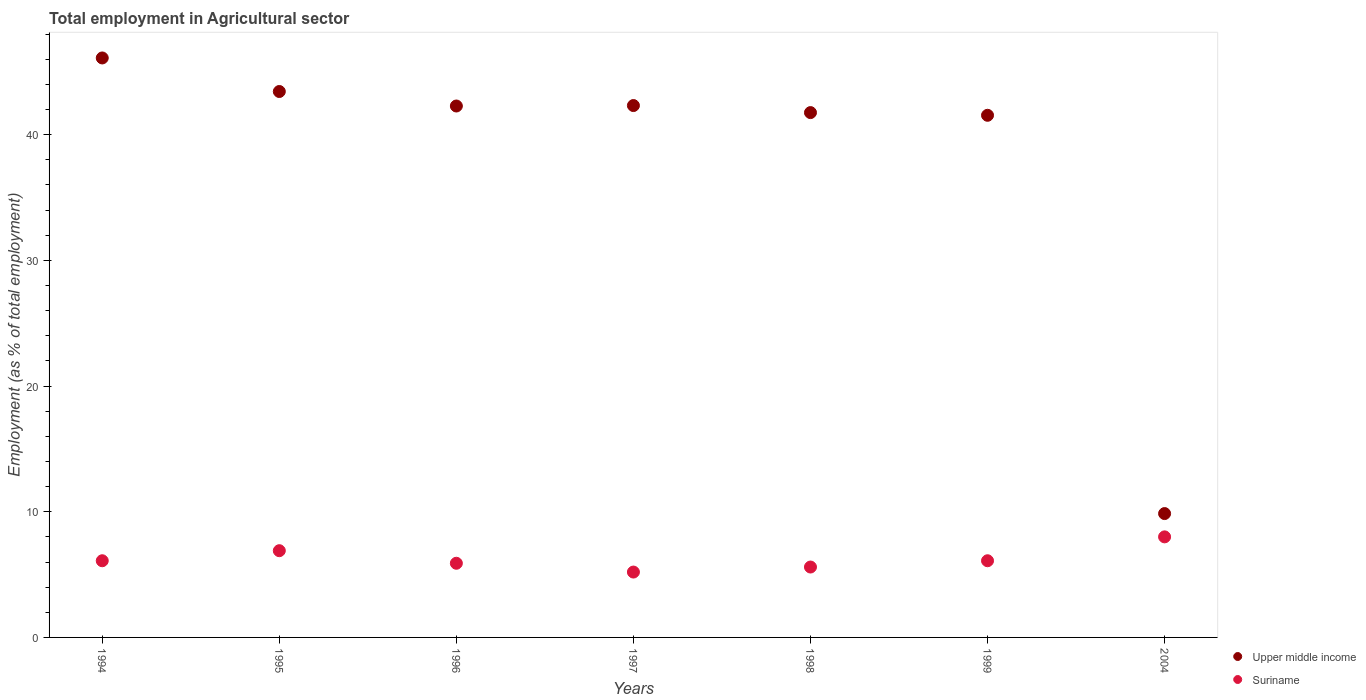What is the employment in agricultural sector in Upper middle income in 1994?
Your answer should be compact. 46.1. Across all years, what is the maximum employment in agricultural sector in Upper middle income?
Make the answer very short. 46.1. Across all years, what is the minimum employment in agricultural sector in Suriname?
Keep it short and to the point. 5.2. In which year was the employment in agricultural sector in Upper middle income maximum?
Keep it short and to the point. 1994. In which year was the employment in agricultural sector in Suriname minimum?
Keep it short and to the point. 1997. What is the total employment in agricultural sector in Upper middle income in the graph?
Provide a succinct answer. 267.26. What is the difference between the employment in agricultural sector in Upper middle income in 1994 and that in 1996?
Offer a terse response. 3.82. What is the difference between the employment in agricultural sector in Suriname in 1994 and the employment in agricultural sector in Upper middle income in 1996?
Your answer should be compact. -36.18. What is the average employment in agricultural sector in Upper middle income per year?
Offer a very short reply. 38.18. In the year 1997, what is the difference between the employment in agricultural sector in Suriname and employment in agricultural sector in Upper middle income?
Offer a terse response. -37.11. What is the difference between the highest and the second highest employment in agricultural sector in Upper middle income?
Offer a terse response. 2.67. What is the difference between the highest and the lowest employment in agricultural sector in Suriname?
Offer a terse response. 2.8. In how many years, is the employment in agricultural sector in Suriname greater than the average employment in agricultural sector in Suriname taken over all years?
Offer a terse response. 2. Is the sum of the employment in agricultural sector in Upper middle income in 1995 and 2004 greater than the maximum employment in agricultural sector in Suriname across all years?
Provide a short and direct response. Yes. Is the employment in agricultural sector in Suriname strictly less than the employment in agricultural sector in Upper middle income over the years?
Offer a very short reply. Yes. Does the graph contain grids?
Your response must be concise. No. What is the title of the graph?
Make the answer very short. Total employment in Agricultural sector. Does "Guyana" appear as one of the legend labels in the graph?
Offer a very short reply. No. What is the label or title of the X-axis?
Keep it short and to the point. Years. What is the label or title of the Y-axis?
Ensure brevity in your answer.  Employment (as % of total employment). What is the Employment (as % of total employment) in Upper middle income in 1994?
Ensure brevity in your answer.  46.1. What is the Employment (as % of total employment) of Suriname in 1994?
Offer a terse response. 6.1. What is the Employment (as % of total employment) in Upper middle income in 1995?
Provide a succinct answer. 43.43. What is the Employment (as % of total employment) in Suriname in 1995?
Provide a succinct answer. 6.9. What is the Employment (as % of total employment) in Upper middle income in 1996?
Make the answer very short. 42.28. What is the Employment (as % of total employment) in Suriname in 1996?
Offer a terse response. 5.9. What is the Employment (as % of total employment) of Upper middle income in 1997?
Give a very brief answer. 42.31. What is the Employment (as % of total employment) of Suriname in 1997?
Make the answer very short. 5.2. What is the Employment (as % of total employment) in Upper middle income in 1998?
Provide a succinct answer. 41.75. What is the Employment (as % of total employment) of Suriname in 1998?
Offer a terse response. 5.6. What is the Employment (as % of total employment) in Upper middle income in 1999?
Provide a short and direct response. 41.54. What is the Employment (as % of total employment) in Suriname in 1999?
Your answer should be very brief. 6.1. What is the Employment (as % of total employment) of Upper middle income in 2004?
Offer a terse response. 9.85. What is the Employment (as % of total employment) of Suriname in 2004?
Keep it short and to the point. 8. Across all years, what is the maximum Employment (as % of total employment) in Upper middle income?
Ensure brevity in your answer.  46.1. Across all years, what is the maximum Employment (as % of total employment) in Suriname?
Make the answer very short. 8. Across all years, what is the minimum Employment (as % of total employment) in Upper middle income?
Provide a short and direct response. 9.85. Across all years, what is the minimum Employment (as % of total employment) of Suriname?
Your answer should be very brief. 5.2. What is the total Employment (as % of total employment) in Upper middle income in the graph?
Your response must be concise. 267.26. What is the total Employment (as % of total employment) of Suriname in the graph?
Offer a very short reply. 43.8. What is the difference between the Employment (as % of total employment) in Upper middle income in 1994 and that in 1995?
Your answer should be compact. 2.67. What is the difference between the Employment (as % of total employment) of Suriname in 1994 and that in 1995?
Give a very brief answer. -0.8. What is the difference between the Employment (as % of total employment) of Upper middle income in 1994 and that in 1996?
Your answer should be compact. 3.82. What is the difference between the Employment (as % of total employment) in Upper middle income in 1994 and that in 1997?
Offer a terse response. 3.79. What is the difference between the Employment (as % of total employment) of Upper middle income in 1994 and that in 1998?
Offer a terse response. 4.35. What is the difference between the Employment (as % of total employment) of Upper middle income in 1994 and that in 1999?
Your answer should be very brief. 4.56. What is the difference between the Employment (as % of total employment) of Upper middle income in 1994 and that in 2004?
Provide a succinct answer. 36.25. What is the difference between the Employment (as % of total employment) of Suriname in 1994 and that in 2004?
Offer a very short reply. -1.9. What is the difference between the Employment (as % of total employment) of Upper middle income in 1995 and that in 1996?
Your answer should be compact. 1.15. What is the difference between the Employment (as % of total employment) in Upper middle income in 1995 and that in 1997?
Provide a short and direct response. 1.12. What is the difference between the Employment (as % of total employment) in Upper middle income in 1995 and that in 1998?
Make the answer very short. 1.68. What is the difference between the Employment (as % of total employment) in Suriname in 1995 and that in 1998?
Keep it short and to the point. 1.3. What is the difference between the Employment (as % of total employment) of Upper middle income in 1995 and that in 1999?
Offer a terse response. 1.89. What is the difference between the Employment (as % of total employment) in Upper middle income in 1995 and that in 2004?
Provide a succinct answer. 33.58. What is the difference between the Employment (as % of total employment) of Suriname in 1995 and that in 2004?
Provide a succinct answer. -1.1. What is the difference between the Employment (as % of total employment) in Upper middle income in 1996 and that in 1997?
Offer a very short reply. -0.04. What is the difference between the Employment (as % of total employment) of Upper middle income in 1996 and that in 1998?
Your response must be concise. 0.52. What is the difference between the Employment (as % of total employment) in Suriname in 1996 and that in 1998?
Your answer should be compact. 0.3. What is the difference between the Employment (as % of total employment) in Upper middle income in 1996 and that in 1999?
Offer a terse response. 0.74. What is the difference between the Employment (as % of total employment) in Upper middle income in 1996 and that in 2004?
Your answer should be compact. 32.42. What is the difference between the Employment (as % of total employment) in Suriname in 1996 and that in 2004?
Provide a short and direct response. -2.1. What is the difference between the Employment (as % of total employment) of Upper middle income in 1997 and that in 1998?
Your response must be concise. 0.56. What is the difference between the Employment (as % of total employment) of Upper middle income in 1997 and that in 1999?
Offer a very short reply. 0.77. What is the difference between the Employment (as % of total employment) of Upper middle income in 1997 and that in 2004?
Your response must be concise. 32.46. What is the difference between the Employment (as % of total employment) in Suriname in 1997 and that in 2004?
Provide a short and direct response. -2.8. What is the difference between the Employment (as % of total employment) of Upper middle income in 1998 and that in 1999?
Your answer should be very brief. 0.21. What is the difference between the Employment (as % of total employment) in Suriname in 1998 and that in 1999?
Make the answer very short. -0.5. What is the difference between the Employment (as % of total employment) in Upper middle income in 1998 and that in 2004?
Give a very brief answer. 31.9. What is the difference between the Employment (as % of total employment) in Upper middle income in 1999 and that in 2004?
Your response must be concise. 31.68. What is the difference between the Employment (as % of total employment) of Suriname in 1999 and that in 2004?
Your answer should be very brief. -1.9. What is the difference between the Employment (as % of total employment) of Upper middle income in 1994 and the Employment (as % of total employment) of Suriname in 1995?
Provide a succinct answer. 39.2. What is the difference between the Employment (as % of total employment) of Upper middle income in 1994 and the Employment (as % of total employment) of Suriname in 1996?
Your answer should be compact. 40.2. What is the difference between the Employment (as % of total employment) in Upper middle income in 1994 and the Employment (as % of total employment) in Suriname in 1997?
Make the answer very short. 40.9. What is the difference between the Employment (as % of total employment) of Upper middle income in 1994 and the Employment (as % of total employment) of Suriname in 1998?
Offer a terse response. 40.5. What is the difference between the Employment (as % of total employment) in Upper middle income in 1994 and the Employment (as % of total employment) in Suriname in 1999?
Ensure brevity in your answer.  40. What is the difference between the Employment (as % of total employment) of Upper middle income in 1994 and the Employment (as % of total employment) of Suriname in 2004?
Your answer should be very brief. 38.1. What is the difference between the Employment (as % of total employment) in Upper middle income in 1995 and the Employment (as % of total employment) in Suriname in 1996?
Ensure brevity in your answer.  37.53. What is the difference between the Employment (as % of total employment) in Upper middle income in 1995 and the Employment (as % of total employment) in Suriname in 1997?
Offer a terse response. 38.23. What is the difference between the Employment (as % of total employment) of Upper middle income in 1995 and the Employment (as % of total employment) of Suriname in 1998?
Give a very brief answer. 37.83. What is the difference between the Employment (as % of total employment) of Upper middle income in 1995 and the Employment (as % of total employment) of Suriname in 1999?
Offer a very short reply. 37.33. What is the difference between the Employment (as % of total employment) in Upper middle income in 1995 and the Employment (as % of total employment) in Suriname in 2004?
Ensure brevity in your answer.  35.43. What is the difference between the Employment (as % of total employment) of Upper middle income in 1996 and the Employment (as % of total employment) of Suriname in 1997?
Offer a very short reply. 37.08. What is the difference between the Employment (as % of total employment) of Upper middle income in 1996 and the Employment (as % of total employment) of Suriname in 1998?
Your response must be concise. 36.68. What is the difference between the Employment (as % of total employment) of Upper middle income in 1996 and the Employment (as % of total employment) of Suriname in 1999?
Provide a short and direct response. 36.18. What is the difference between the Employment (as % of total employment) of Upper middle income in 1996 and the Employment (as % of total employment) of Suriname in 2004?
Offer a terse response. 34.28. What is the difference between the Employment (as % of total employment) in Upper middle income in 1997 and the Employment (as % of total employment) in Suriname in 1998?
Offer a terse response. 36.71. What is the difference between the Employment (as % of total employment) of Upper middle income in 1997 and the Employment (as % of total employment) of Suriname in 1999?
Give a very brief answer. 36.21. What is the difference between the Employment (as % of total employment) of Upper middle income in 1997 and the Employment (as % of total employment) of Suriname in 2004?
Provide a succinct answer. 34.31. What is the difference between the Employment (as % of total employment) in Upper middle income in 1998 and the Employment (as % of total employment) in Suriname in 1999?
Your response must be concise. 35.65. What is the difference between the Employment (as % of total employment) in Upper middle income in 1998 and the Employment (as % of total employment) in Suriname in 2004?
Your response must be concise. 33.75. What is the difference between the Employment (as % of total employment) of Upper middle income in 1999 and the Employment (as % of total employment) of Suriname in 2004?
Provide a short and direct response. 33.54. What is the average Employment (as % of total employment) in Upper middle income per year?
Keep it short and to the point. 38.18. What is the average Employment (as % of total employment) of Suriname per year?
Keep it short and to the point. 6.26. In the year 1994, what is the difference between the Employment (as % of total employment) of Upper middle income and Employment (as % of total employment) of Suriname?
Make the answer very short. 40. In the year 1995, what is the difference between the Employment (as % of total employment) in Upper middle income and Employment (as % of total employment) in Suriname?
Give a very brief answer. 36.53. In the year 1996, what is the difference between the Employment (as % of total employment) in Upper middle income and Employment (as % of total employment) in Suriname?
Your answer should be compact. 36.38. In the year 1997, what is the difference between the Employment (as % of total employment) in Upper middle income and Employment (as % of total employment) in Suriname?
Your answer should be compact. 37.11. In the year 1998, what is the difference between the Employment (as % of total employment) of Upper middle income and Employment (as % of total employment) of Suriname?
Provide a succinct answer. 36.15. In the year 1999, what is the difference between the Employment (as % of total employment) of Upper middle income and Employment (as % of total employment) of Suriname?
Offer a terse response. 35.44. In the year 2004, what is the difference between the Employment (as % of total employment) in Upper middle income and Employment (as % of total employment) in Suriname?
Your answer should be compact. 1.85. What is the ratio of the Employment (as % of total employment) of Upper middle income in 1994 to that in 1995?
Provide a short and direct response. 1.06. What is the ratio of the Employment (as % of total employment) of Suriname in 1994 to that in 1995?
Your answer should be very brief. 0.88. What is the ratio of the Employment (as % of total employment) in Upper middle income in 1994 to that in 1996?
Your answer should be compact. 1.09. What is the ratio of the Employment (as % of total employment) of Suriname in 1994 to that in 1996?
Your answer should be very brief. 1.03. What is the ratio of the Employment (as % of total employment) in Upper middle income in 1994 to that in 1997?
Provide a succinct answer. 1.09. What is the ratio of the Employment (as % of total employment) of Suriname in 1994 to that in 1997?
Your response must be concise. 1.17. What is the ratio of the Employment (as % of total employment) of Upper middle income in 1994 to that in 1998?
Ensure brevity in your answer.  1.1. What is the ratio of the Employment (as % of total employment) of Suriname in 1994 to that in 1998?
Ensure brevity in your answer.  1.09. What is the ratio of the Employment (as % of total employment) of Upper middle income in 1994 to that in 1999?
Offer a very short reply. 1.11. What is the ratio of the Employment (as % of total employment) in Suriname in 1994 to that in 1999?
Provide a succinct answer. 1. What is the ratio of the Employment (as % of total employment) in Upper middle income in 1994 to that in 2004?
Offer a terse response. 4.68. What is the ratio of the Employment (as % of total employment) of Suriname in 1994 to that in 2004?
Ensure brevity in your answer.  0.76. What is the ratio of the Employment (as % of total employment) in Upper middle income in 1995 to that in 1996?
Make the answer very short. 1.03. What is the ratio of the Employment (as % of total employment) of Suriname in 1995 to that in 1996?
Make the answer very short. 1.17. What is the ratio of the Employment (as % of total employment) in Upper middle income in 1995 to that in 1997?
Your answer should be very brief. 1.03. What is the ratio of the Employment (as % of total employment) in Suriname in 1995 to that in 1997?
Your response must be concise. 1.33. What is the ratio of the Employment (as % of total employment) of Upper middle income in 1995 to that in 1998?
Ensure brevity in your answer.  1.04. What is the ratio of the Employment (as % of total employment) of Suriname in 1995 to that in 1998?
Provide a succinct answer. 1.23. What is the ratio of the Employment (as % of total employment) in Upper middle income in 1995 to that in 1999?
Offer a very short reply. 1.05. What is the ratio of the Employment (as % of total employment) of Suriname in 1995 to that in 1999?
Offer a very short reply. 1.13. What is the ratio of the Employment (as % of total employment) in Upper middle income in 1995 to that in 2004?
Provide a succinct answer. 4.41. What is the ratio of the Employment (as % of total employment) of Suriname in 1995 to that in 2004?
Provide a succinct answer. 0.86. What is the ratio of the Employment (as % of total employment) of Upper middle income in 1996 to that in 1997?
Provide a succinct answer. 1. What is the ratio of the Employment (as % of total employment) of Suriname in 1996 to that in 1997?
Offer a terse response. 1.13. What is the ratio of the Employment (as % of total employment) in Upper middle income in 1996 to that in 1998?
Keep it short and to the point. 1.01. What is the ratio of the Employment (as % of total employment) of Suriname in 1996 to that in 1998?
Offer a very short reply. 1.05. What is the ratio of the Employment (as % of total employment) in Upper middle income in 1996 to that in 1999?
Your response must be concise. 1.02. What is the ratio of the Employment (as % of total employment) in Suriname in 1996 to that in 1999?
Your response must be concise. 0.97. What is the ratio of the Employment (as % of total employment) of Upper middle income in 1996 to that in 2004?
Make the answer very short. 4.29. What is the ratio of the Employment (as % of total employment) of Suriname in 1996 to that in 2004?
Your answer should be very brief. 0.74. What is the ratio of the Employment (as % of total employment) in Upper middle income in 1997 to that in 1998?
Give a very brief answer. 1.01. What is the ratio of the Employment (as % of total employment) of Upper middle income in 1997 to that in 1999?
Ensure brevity in your answer.  1.02. What is the ratio of the Employment (as % of total employment) of Suriname in 1997 to that in 1999?
Your answer should be compact. 0.85. What is the ratio of the Employment (as % of total employment) of Upper middle income in 1997 to that in 2004?
Ensure brevity in your answer.  4.29. What is the ratio of the Employment (as % of total employment) in Suriname in 1997 to that in 2004?
Give a very brief answer. 0.65. What is the ratio of the Employment (as % of total employment) of Suriname in 1998 to that in 1999?
Provide a short and direct response. 0.92. What is the ratio of the Employment (as % of total employment) of Upper middle income in 1998 to that in 2004?
Offer a terse response. 4.24. What is the ratio of the Employment (as % of total employment) in Suriname in 1998 to that in 2004?
Your response must be concise. 0.7. What is the ratio of the Employment (as % of total employment) in Upper middle income in 1999 to that in 2004?
Make the answer very short. 4.22. What is the ratio of the Employment (as % of total employment) in Suriname in 1999 to that in 2004?
Your answer should be very brief. 0.76. What is the difference between the highest and the second highest Employment (as % of total employment) of Upper middle income?
Keep it short and to the point. 2.67. What is the difference between the highest and the lowest Employment (as % of total employment) in Upper middle income?
Ensure brevity in your answer.  36.25. 